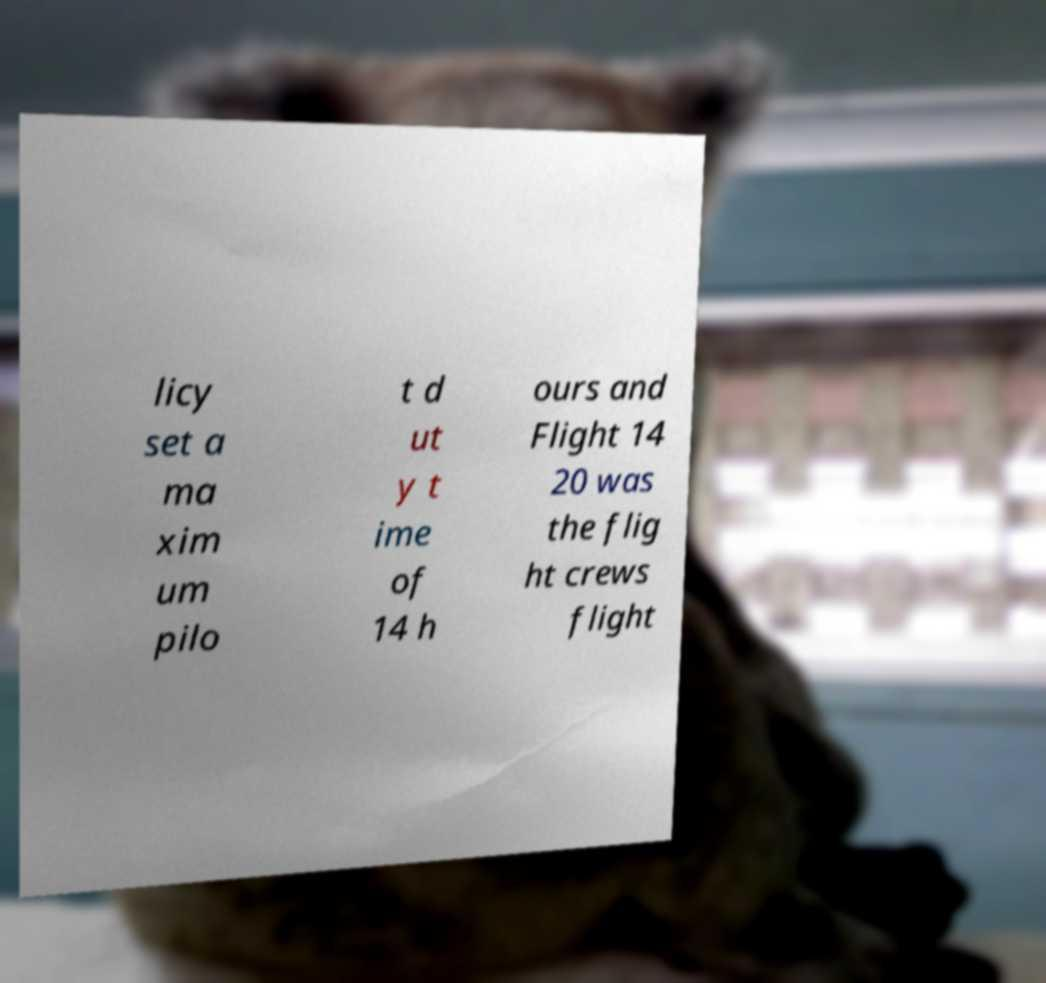Please identify and transcribe the text found in this image. licy set a ma xim um pilo t d ut y t ime of 14 h ours and Flight 14 20 was the flig ht crews flight 